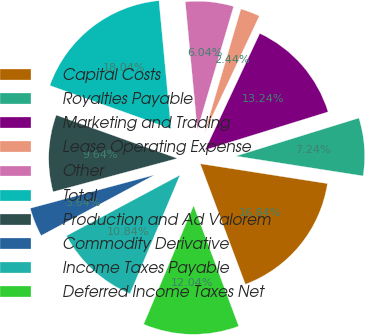Convert chart to OTSL. <chart><loc_0><loc_0><loc_500><loc_500><pie_chart><fcel>Capital Costs<fcel>Royalties Payable<fcel>Marketing and Trading<fcel>Lease Operating Expense<fcel>Other<fcel>Total<fcel>Production and Ad Valorem<fcel>Commodity Derivative<fcel>Income Taxes Payable<fcel>Deferred Income Taxes Net<nl><fcel>16.84%<fcel>7.24%<fcel>13.24%<fcel>2.44%<fcel>6.04%<fcel>18.04%<fcel>9.64%<fcel>3.64%<fcel>10.84%<fcel>12.04%<nl></chart> 